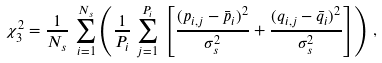<formula> <loc_0><loc_0><loc_500><loc_500>\chi _ { 3 } ^ { 2 } = \frac { 1 } { N _ { s } } \, \sum ^ { N _ { s } } _ { i = 1 } \left ( \frac { 1 } { P _ { i } } \, \sum ^ { P _ { i } } _ { j = 1 } \, \left [ \frac { ( p _ { i , j } - \bar { p } _ { i } ) ^ { 2 } } { \sigma _ { s } ^ { 2 } } + \frac { ( q _ { i , j } - \bar { q } _ { i } ) ^ { 2 } } { \sigma _ { s } ^ { 2 } } \right ] \right ) \, ,</formula> 